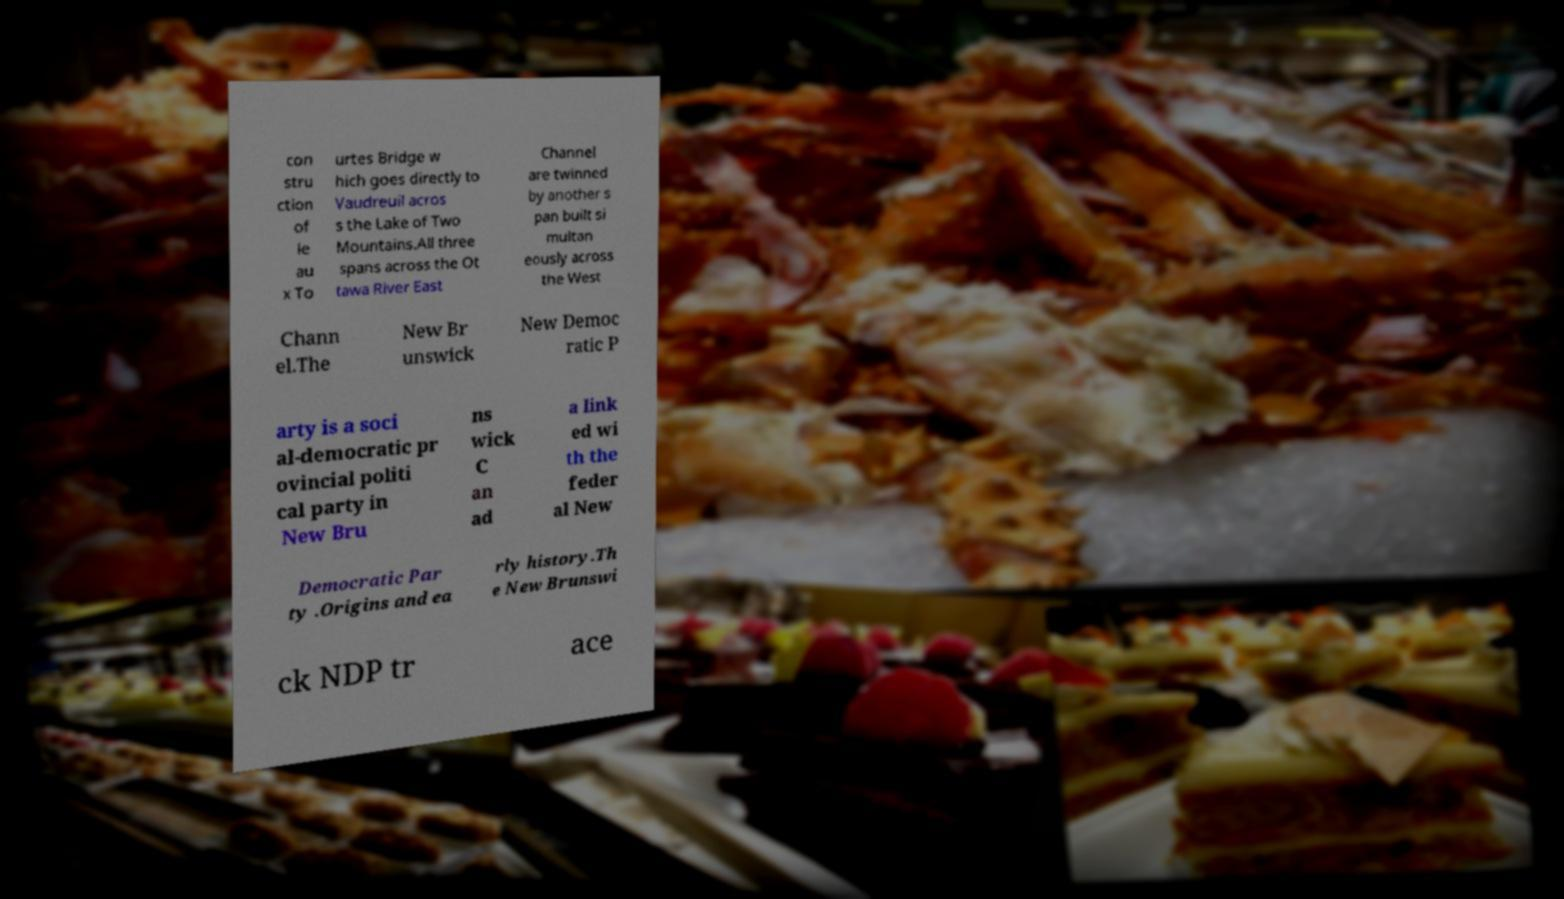Could you extract and type out the text from this image? con stru ction of le au x To urtes Bridge w hich goes directly to Vaudreuil acros s the Lake of Two Mountains.All three spans across the Ot tawa River East Channel are twinned by another s pan built si multan eously across the West Chann el.The New Br unswick New Democ ratic P arty is a soci al-democratic pr ovincial politi cal party in New Bru ns wick C an ad a link ed wi th the feder al New Democratic Par ty .Origins and ea rly history.Th e New Brunswi ck NDP tr ace 